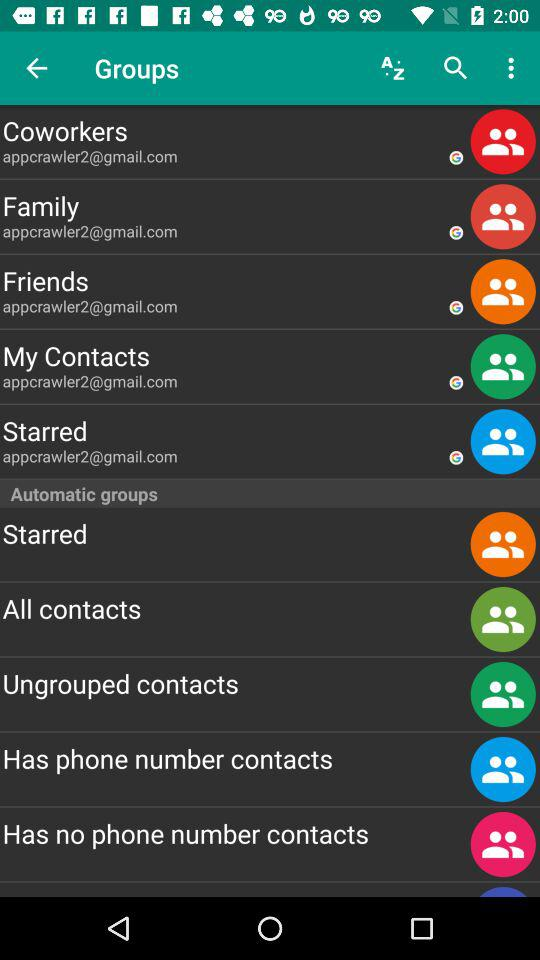What is the email address of "Friends"? The email address is appcrawler2@gmail.com. 